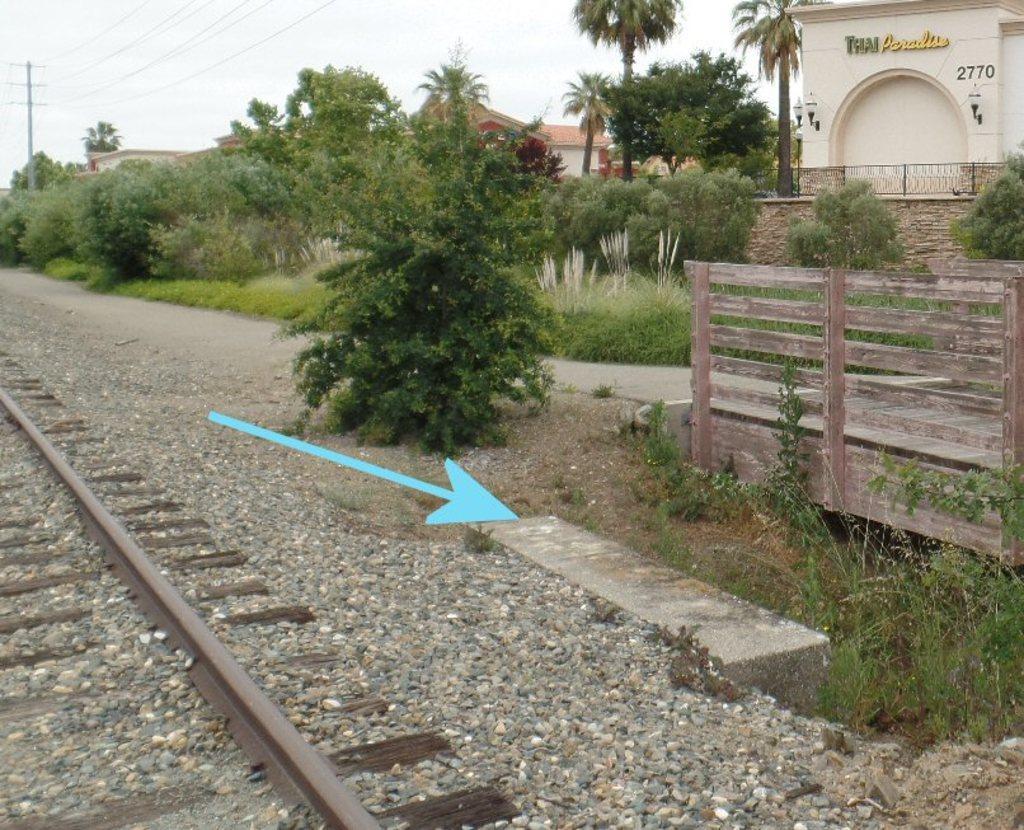Could you give a brief overview of what you see in this image? In the foreground of the image we can see railway track and stones. In the middle of the image we can see trees, houses, a road and a arrow mark which is blue in color. On the top of the image we can see current wires and the sky. 